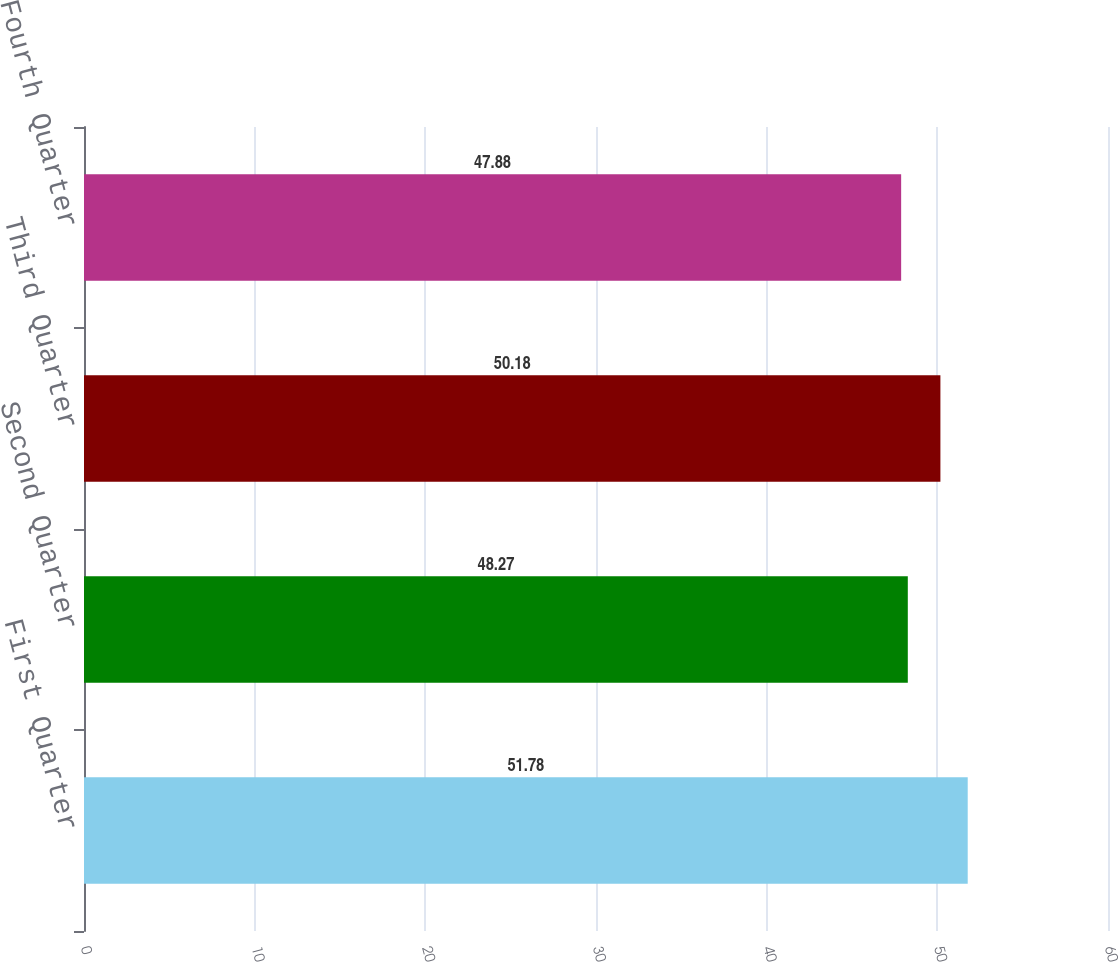Convert chart to OTSL. <chart><loc_0><loc_0><loc_500><loc_500><bar_chart><fcel>First Quarter<fcel>Second Quarter<fcel>Third Quarter<fcel>Fourth Quarter<nl><fcel>51.78<fcel>48.27<fcel>50.18<fcel>47.88<nl></chart> 